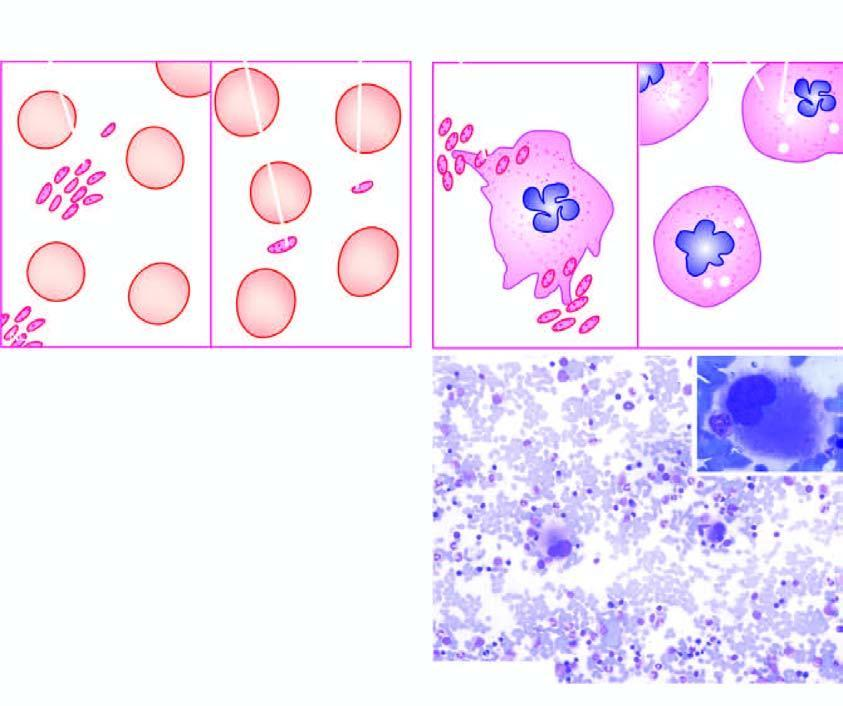what shows presence of reduced number of platelets which are often large?
Answer the question using a single word or phrase. Peripheral blood in itp 